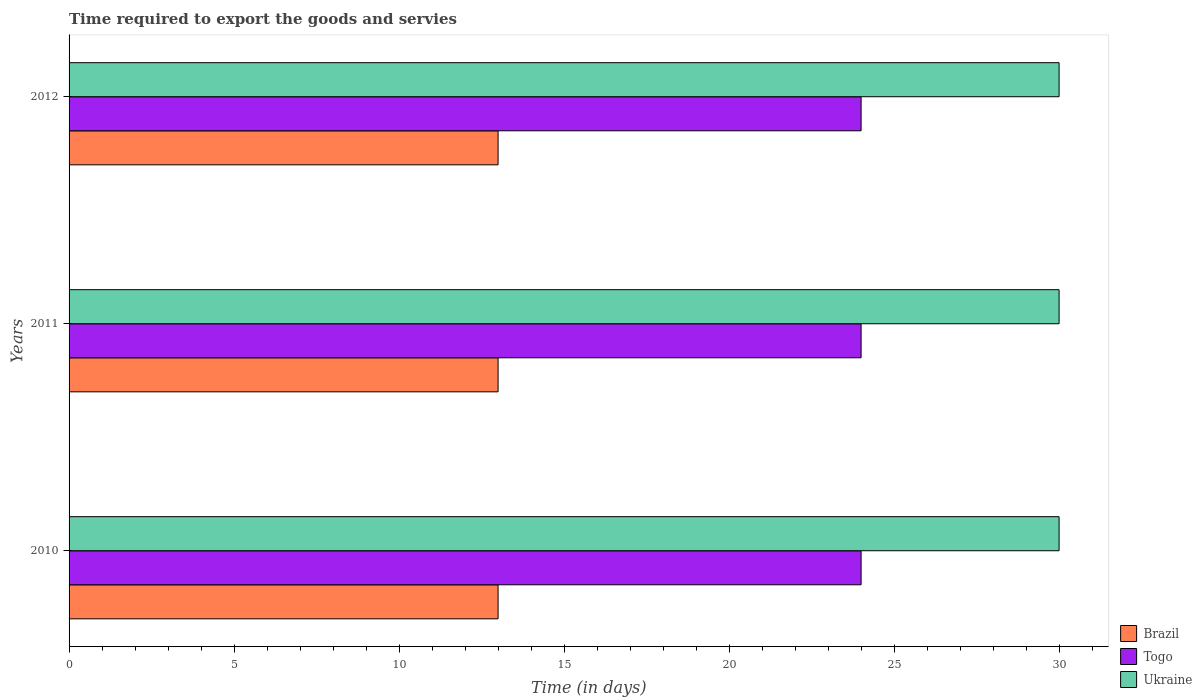How many different coloured bars are there?
Your answer should be compact. 3. How many groups of bars are there?
Your answer should be very brief. 3. Are the number of bars per tick equal to the number of legend labels?
Your answer should be compact. Yes. How many bars are there on the 3rd tick from the bottom?
Offer a very short reply. 3. What is the label of the 2nd group of bars from the top?
Your answer should be compact. 2011. What is the number of days required to export the goods and services in Brazil in 2011?
Your answer should be very brief. 13. Across all years, what is the maximum number of days required to export the goods and services in Brazil?
Give a very brief answer. 13. Across all years, what is the minimum number of days required to export the goods and services in Togo?
Ensure brevity in your answer.  24. In which year was the number of days required to export the goods and services in Brazil minimum?
Your answer should be compact. 2010. What is the difference between the number of days required to export the goods and services in Ukraine in 2011 and the number of days required to export the goods and services in Brazil in 2012?
Your response must be concise. 17. In the year 2012, what is the difference between the number of days required to export the goods and services in Togo and number of days required to export the goods and services in Ukraine?
Keep it short and to the point. -6. In how many years, is the number of days required to export the goods and services in Togo greater than 10 days?
Offer a terse response. 3. Is the difference between the number of days required to export the goods and services in Togo in 2011 and 2012 greater than the difference between the number of days required to export the goods and services in Ukraine in 2011 and 2012?
Provide a succinct answer. No. What is the difference between the highest and the second highest number of days required to export the goods and services in Togo?
Ensure brevity in your answer.  0. What is the difference between the highest and the lowest number of days required to export the goods and services in Togo?
Make the answer very short. 0. What does the 3rd bar from the bottom in 2011 represents?
Offer a terse response. Ukraine. Is it the case that in every year, the sum of the number of days required to export the goods and services in Ukraine and number of days required to export the goods and services in Brazil is greater than the number of days required to export the goods and services in Togo?
Keep it short and to the point. Yes. Are all the bars in the graph horizontal?
Give a very brief answer. Yes. Are the values on the major ticks of X-axis written in scientific E-notation?
Give a very brief answer. No. Does the graph contain any zero values?
Your response must be concise. No. Where does the legend appear in the graph?
Make the answer very short. Bottom right. What is the title of the graph?
Keep it short and to the point. Time required to export the goods and servies. What is the label or title of the X-axis?
Your answer should be compact. Time (in days). What is the label or title of the Y-axis?
Your answer should be compact. Years. What is the Time (in days) of Togo in 2010?
Offer a very short reply. 24. What is the Time (in days) of Brazil in 2011?
Your answer should be very brief. 13. What is the Time (in days) of Togo in 2011?
Ensure brevity in your answer.  24. What is the Time (in days) of Togo in 2012?
Ensure brevity in your answer.  24. Across all years, what is the maximum Time (in days) in Brazil?
Give a very brief answer. 13. Across all years, what is the minimum Time (in days) in Brazil?
Your answer should be very brief. 13. Across all years, what is the minimum Time (in days) of Togo?
Ensure brevity in your answer.  24. Across all years, what is the minimum Time (in days) of Ukraine?
Offer a terse response. 30. What is the total Time (in days) in Brazil in the graph?
Provide a short and direct response. 39. What is the total Time (in days) of Ukraine in the graph?
Your response must be concise. 90. What is the difference between the Time (in days) of Brazil in 2010 and that in 2011?
Your answer should be very brief. 0. What is the difference between the Time (in days) of Ukraine in 2010 and that in 2012?
Provide a short and direct response. 0. What is the difference between the Time (in days) of Togo in 2011 and that in 2012?
Your response must be concise. 0. What is the difference between the Time (in days) of Ukraine in 2011 and that in 2012?
Provide a succinct answer. 0. What is the difference between the Time (in days) of Brazil in 2010 and the Time (in days) of Togo in 2011?
Offer a very short reply. -11. What is the difference between the Time (in days) of Togo in 2010 and the Time (in days) of Ukraine in 2011?
Make the answer very short. -6. What is the average Time (in days) of Brazil per year?
Your answer should be very brief. 13. In the year 2010, what is the difference between the Time (in days) in Brazil and Time (in days) in Togo?
Provide a succinct answer. -11. In the year 2011, what is the difference between the Time (in days) in Brazil and Time (in days) in Togo?
Provide a short and direct response. -11. In the year 2011, what is the difference between the Time (in days) of Brazil and Time (in days) of Ukraine?
Offer a terse response. -17. In the year 2012, what is the difference between the Time (in days) of Brazil and Time (in days) of Ukraine?
Keep it short and to the point. -17. What is the ratio of the Time (in days) in Ukraine in 2010 to that in 2011?
Give a very brief answer. 1. What is the ratio of the Time (in days) in Brazil in 2010 to that in 2012?
Provide a short and direct response. 1. What is the ratio of the Time (in days) in Brazil in 2011 to that in 2012?
Make the answer very short. 1. What is the ratio of the Time (in days) in Togo in 2011 to that in 2012?
Make the answer very short. 1. What is the ratio of the Time (in days) in Ukraine in 2011 to that in 2012?
Give a very brief answer. 1. What is the difference between the highest and the second highest Time (in days) in Togo?
Your answer should be compact. 0. What is the difference between the highest and the second highest Time (in days) of Ukraine?
Ensure brevity in your answer.  0. What is the difference between the highest and the lowest Time (in days) of Brazil?
Provide a short and direct response. 0. What is the difference between the highest and the lowest Time (in days) of Togo?
Your response must be concise. 0. What is the difference between the highest and the lowest Time (in days) in Ukraine?
Keep it short and to the point. 0. 